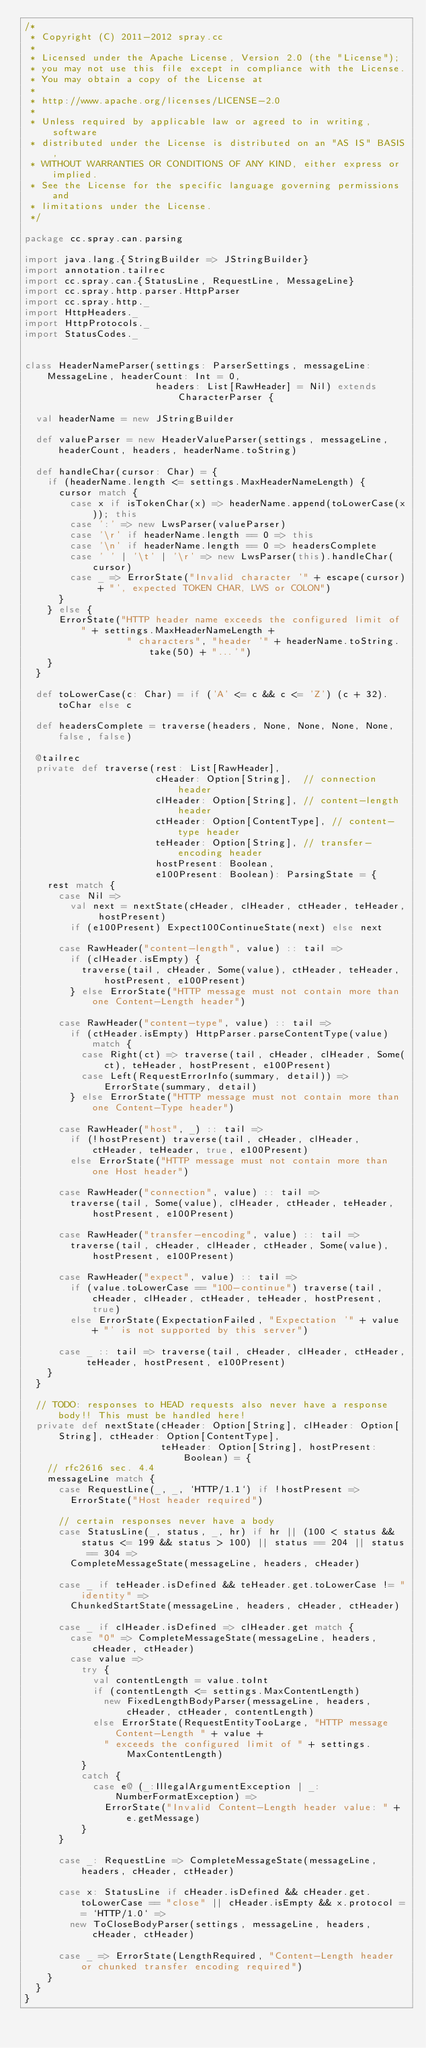<code> <loc_0><loc_0><loc_500><loc_500><_Scala_>/*
 * Copyright (C) 2011-2012 spray.cc
 *
 * Licensed under the Apache License, Version 2.0 (the "License");
 * you may not use this file except in compliance with the License.
 * You may obtain a copy of the License at
 *
 * http://www.apache.org/licenses/LICENSE-2.0
 *
 * Unless required by applicable law or agreed to in writing, software
 * distributed under the License is distributed on an "AS IS" BASIS,
 * WITHOUT WARRANTIES OR CONDITIONS OF ANY KIND, either express or implied.
 * See the License for the specific language governing permissions and
 * limitations under the License.
 */

package cc.spray.can.parsing

import java.lang.{StringBuilder => JStringBuilder}
import annotation.tailrec
import cc.spray.can.{StatusLine, RequestLine, MessageLine}
import cc.spray.http.parser.HttpParser
import cc.spray.http._
import HttpHeaders._
import HttpProtocols._
import StatusCodes._


class HeaderNameParser(settings: ParserSettings, messageLine: MessageLine, headerCount: Int = 0,
                       headers: List[RawHeader] = Nil) extends CharacterParser {

  val headerName = new JStringBuilder

  def valueParser = new HeaderValueParser(settings, messageLine, headerCount, headers, headerName.toString)

  def handleChar(cursor: Char) = {
    if (headerName.length <= settings.MaxHeaderNameLength) {
      cursor match {
        case x if isTokenChar(x) => headerName.append(toLowerCase(x)); this
        case ':' => new LwsParser(valueParser)
        case '\r' if headerName.length == 0 => this
        case '\n' if headerName.length == 0 => headersComplete
        case ' ' | '\t' | '\r' => new LwsParser(this).handleChar(cursor)
        case _ => ErrorState("Invalid character '" + escape(cursor) + "', expected TOKEN CHAR, LWS or COLON")
      }
    } else {
      ErrorState("HTTP header name exceeds the configured limit of " + settings.MaxHeaderNameLength +
                  " characters", "header '" + headerName.toString.take(50) + "...'")
    }
  }

  def toLowerCase(c: Char) = if ('A' <= c && c <= 'Z') (c + 32).toChar else c

  def headersComplete = traverse(headers, None, None, None, None, false, false)

  @tailrec
  private def traverse(rest: List[RawHeader],
                       cHeader: Option[String],  // connection header
                       clHeader: Option[String], // content-length header
                       ctHeader: Option[ContentType], // content-type header
                       teHeader: Option[String], // transfer-encoding header
                       hostPresent: Boolean,
                       e100Present: Boolean): ParsingState = {
    rest match {
      case Nil =>
        val next = nextState(cHeader, clHeader, ctHeader, teHeader, hostPresent)
        if (e100Present) Expect100ContinueState(next) else next

      case RawHeader("content-length", value) :: tail =>
        if (clHeader.isEmpty) {
          traverse(tail, cHeader, Some(value), ctHeader, teHeader, hostPresent, e100Present)
        } else ErrorState("HTTP message must not contain more than one Content-Length header")

      case RawHeader("content-type", value) :: tail =>
        if (ctHeader.isEmpty) HttpParser.parseContentType(value) match {
          case Right(ct) => traverse(tail, cHeader, clHeader, Some(ct), teHeader, hostPresent, e100Present)
          case Left(RequestErrorInfo(summary, detail)) => ErrorState(summary, detail)
        } else ErrorState("HTTP message must not contain more than one Content-Type header")

      case RawHeader("host", _) :: tail =>
        if (!hostPresent) traverse(tail, cHeader, clHeader, ctHeader, teHeader, true, e100Present)
        else ErrorState("HTTP message must not contain more than one Host header")

      case RawHeader("connection", value) :: tail =>
        traverse(tail, Some(value), clHeader, ctHeader, teHeader, hostPresent, e100Present)

      case RawHeader("transfer-encoding", value) :: tail =>
        traverse(tail, cHeader, clHeader, ctHeader, Some(value), hostPresent, e100Present)

      case RawHeader("expect", value) :: tail =>
        if (value.toLowerCase == "100-continue") traverse(tail, cHeader, clHeader, ctHeader, teHeader, hostPresent, true)
        else ErrorState(ExpectationFailed, "Expectation '" + value + "' is not supported by this server")

      case _ :: tail => traverse(tail, cHeader, clHeader, ctHeader, teHeader, hostPresent, e100Present)
    }
  }

  // TODO: responses to HEAD requests also never have a response body!! This must be handled here!
  private def nextState(cHeader: Option[String], clHeader: Option[String], ctHeader: Option[ContentType],
                        teHeader: Option[String], hostPresent: Boolean) = {
    // rfc2616 sec. 4.4
    messageLine match {
      case RequestLine(_, _, `HTTP/1.1`) if !hostPresent =>
        ErrorState("Host header required")

      // certain responses never have a body
      case StatusLine(_, status, _, hr) if hr || (100 < status && status <= 199 && status > 100) || status == 204 || status == 304 =>
        CompleteMessageState(messageLine, headers, cHeader)

      case _ if teHeader.isDefined && teHeader.get.toLowerCase != "identity" =>
        ChunkedStartState(messageLine, headers, cHeader, ctHeader)

      case _ if clHeader.isDefined => clHeader.get match {
        case "0" => CompleteMessageState(messageLine, headers, cHeader, ctHeader)
        case value =>
          try {
            val contentLength = value.toInt
            if (contentLength <= settings.MaxContentLength)
              new FixedLengthBodyParser(messageLine, headers, cHeader, ctHeader, contentLength)
            else ErrorState(RequestEntityTooLarge, "HTTP message Content-Length " + value +
              " exceeds the configured limit of " + settings.MaxContentLength)
          }
          catch {
            case e@ (_:IllegalArgumentException | _:NumberFormatException) =>
              ErrorState("Invalid Content-Length header value: " + e.getMessage)
          }
      }

      case _: RequestLine => CompleteMessageState(messageLine, headers, cHeader, ctHeader)

      case x: StatusLine if cHeader.isDefined && cHeader.get.toLowerCase == "close" || cHeader.isEmpty && x.protocol == `HTTP/1.0` =>
        new ToCloseBodyParser(settings, messageLine, headers, cHeader, ctHeader)

      case _ => ErrorState(LengthRequired, "Content-Length header or chunked transfer encoding required")
    }
  }
}</code> 